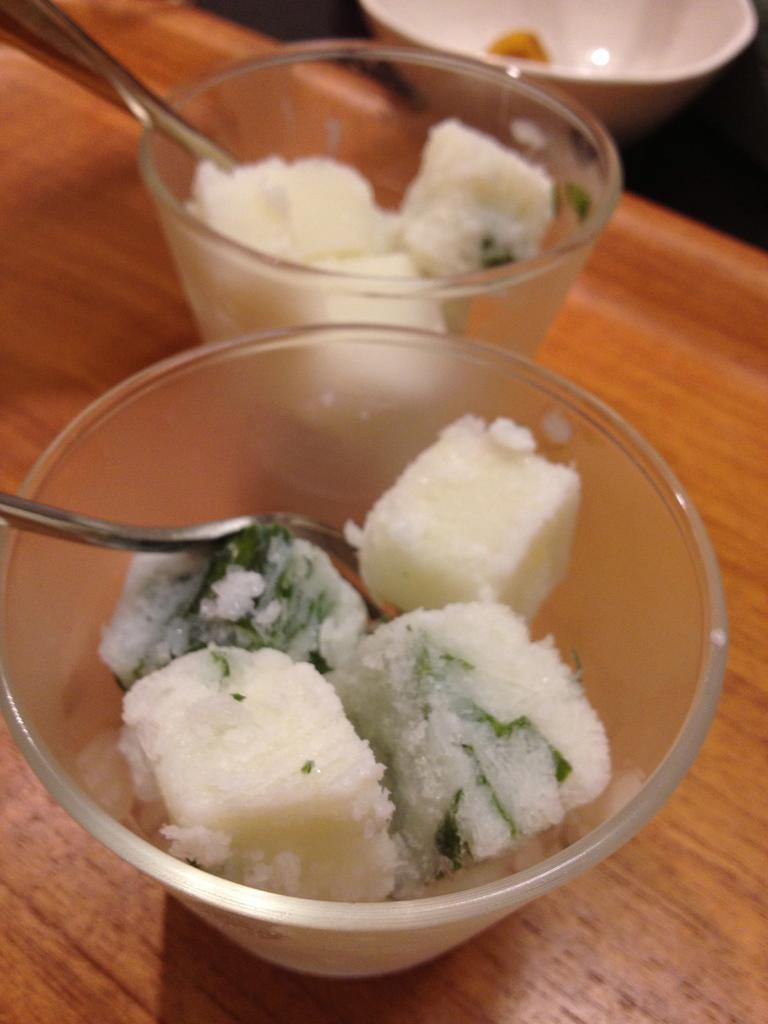What type of furniture is present in the image? There is a table in the image. What objects are on the table? There are bowls and spoons on the table. What is placed on the table that might be consumed? There is food placed on the table. Where is the cushion located in the image? There is no cushion present in the image. What type of bird can be seen sitting on the food in the image? There is no bird, such as a crow, present in the image. 